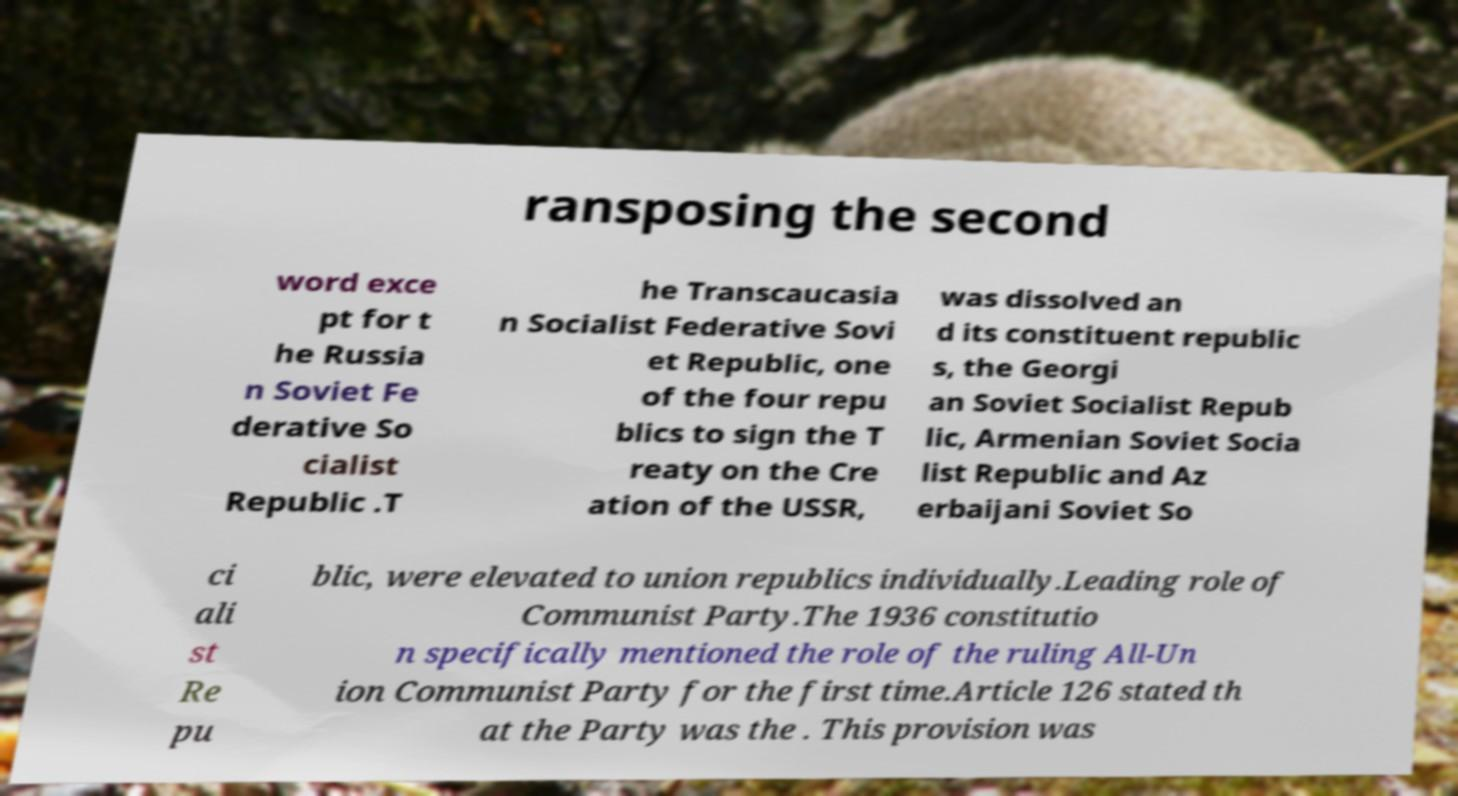Please identify and transcribe the text found in this image. ransposing the second word exce pt for t he Russia n Soviet Fe derative So cialist Republic .T he Transcaucasia n Socialist Federative Sovi et Republic, one of the four repu blics to sign the T reaty on the Cre ation of the USSR, was dissolved an d its constituent republic s, the Georgi an Soviet Socialist Repub lic, Armenian Soviet Socia list Republic and Az erbaijani Soviet So ci ali st Re pu blic, were elevated to union republics individually.Leading role of Communist Party.The 1936 constitutio n specifically mentioned the role of the ruling All-Un ion Communist Party for the first time.Article 126 stated th at the Party was the . This provision was 